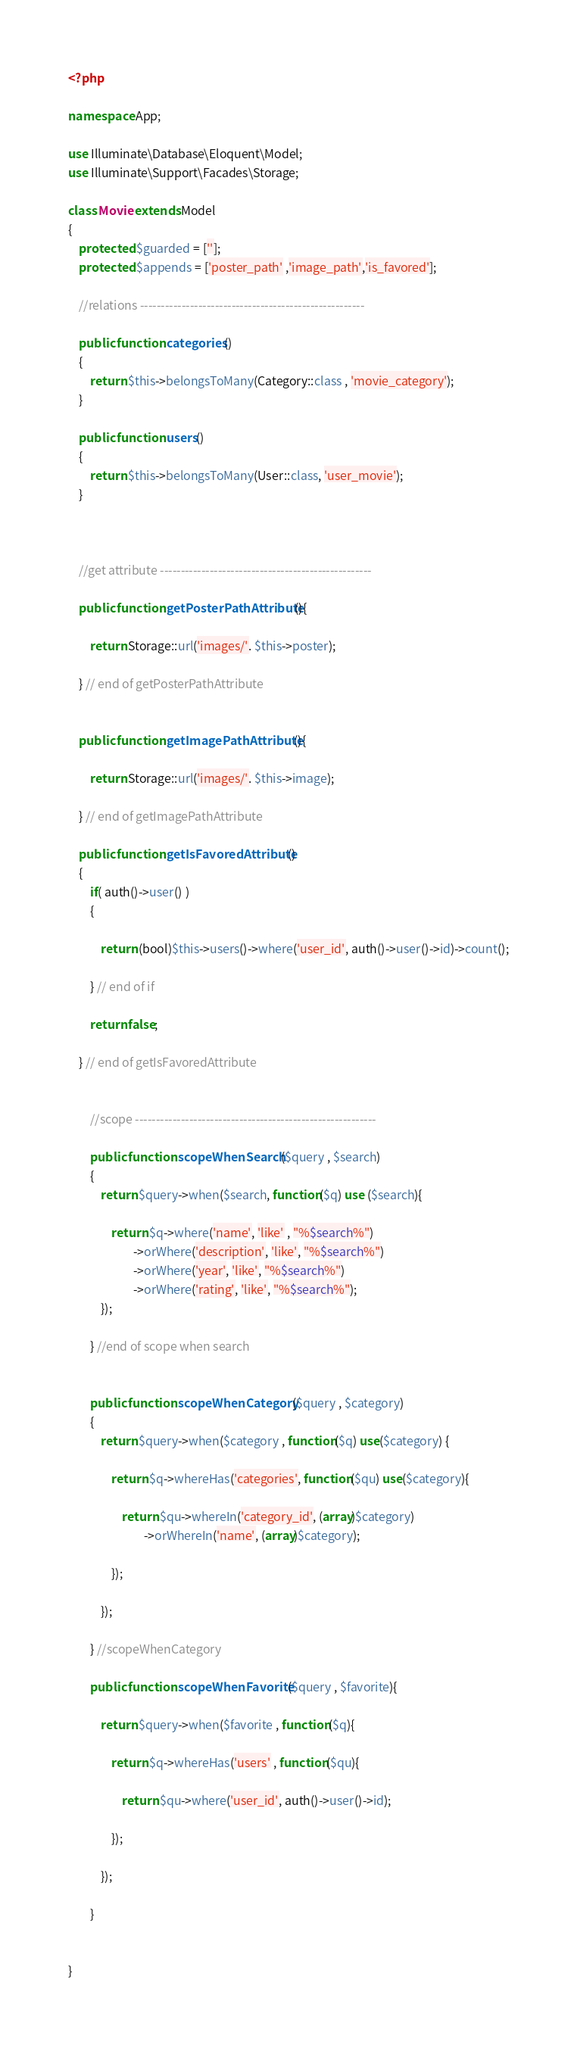<code> <loc_0><loc_0><loc_500><loc_500><_PHP_><?php

namespace App;

use Illuminate\Database\Eloquent\Model;
use Illuminate\Support\Facades\Storage;

class Movie extends Model
{
    protected $guarded = [''];
    protected $appends = ['poster_path' ,'image_path','is_favored'];

    //relations ------------------------------------------------------

    public function categories()
    {
        return $this->belongsToMany(Category::class , 'movie_category');
    }

    public function users()
    {
        return $this->belongsToMany(User::class, 'user_movie');
    }



    //get attribute ---------------------------------------------------

    public function getPosterPathAttribute(){

        return Storage::url('images/'. $this->poster);

    } // end of getPosterPathAttribute


    public function getImagePathAttribute(){

        return Storage::url('images/'. $this->image);

    } // end of getImagePathAttribute

    public function getIsFavoredAttribute()
    {
        if( auth()->user() )
        {

            return (bool)$this->users()->where('user_id', auth()->user()->id)->count();

        } // end of if

        return false;

    } // end of getIsFavoredAttribute


        //scope ----------------------------------------------------------

        public function scopeWhenSearch($query , $search)
        {
            return $query->when($search, function($q) use ($search){

                return $q->where('name', 'like' , "%$search%")
                        ->orWhere('description', 'like', "%$search%")
                        ->orWhere('year', 'like', "%$search%")
                        ->orWhere('rating', 'like', "%$search%");
            });

        } //end of scope when search


        public function scopeWhenCategory($query , $category)
        {
            return $query->when($category , function($q) use($category) {

                return $q->whereHas('categories', function($qu) use($category){

                    return $qu->whereIn('category_id', (array)$category)
                            ->orWhereIn('name', (array)$category);

                });

            });

        } //scopeWhenCategory

        public function scopeWhenFavorite($query , $favorite){

            return $query->when($favorite , function($q){

                return $q->whereHas('users' , function($qu){

                    return $qu->where('user_id', auth()->user()->id);
                    
                });

            });

        }


}
</code> 